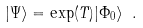<formula> <loc_0><loc_0><loc_500><loc_500>| \Psi \rangle = \exp ( T ) | \Phi _ { 0 } \rangle \ .</formula> 